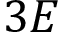<formula> <loc_0><loc_0><loc_500><loc_500>3 E</formula> 